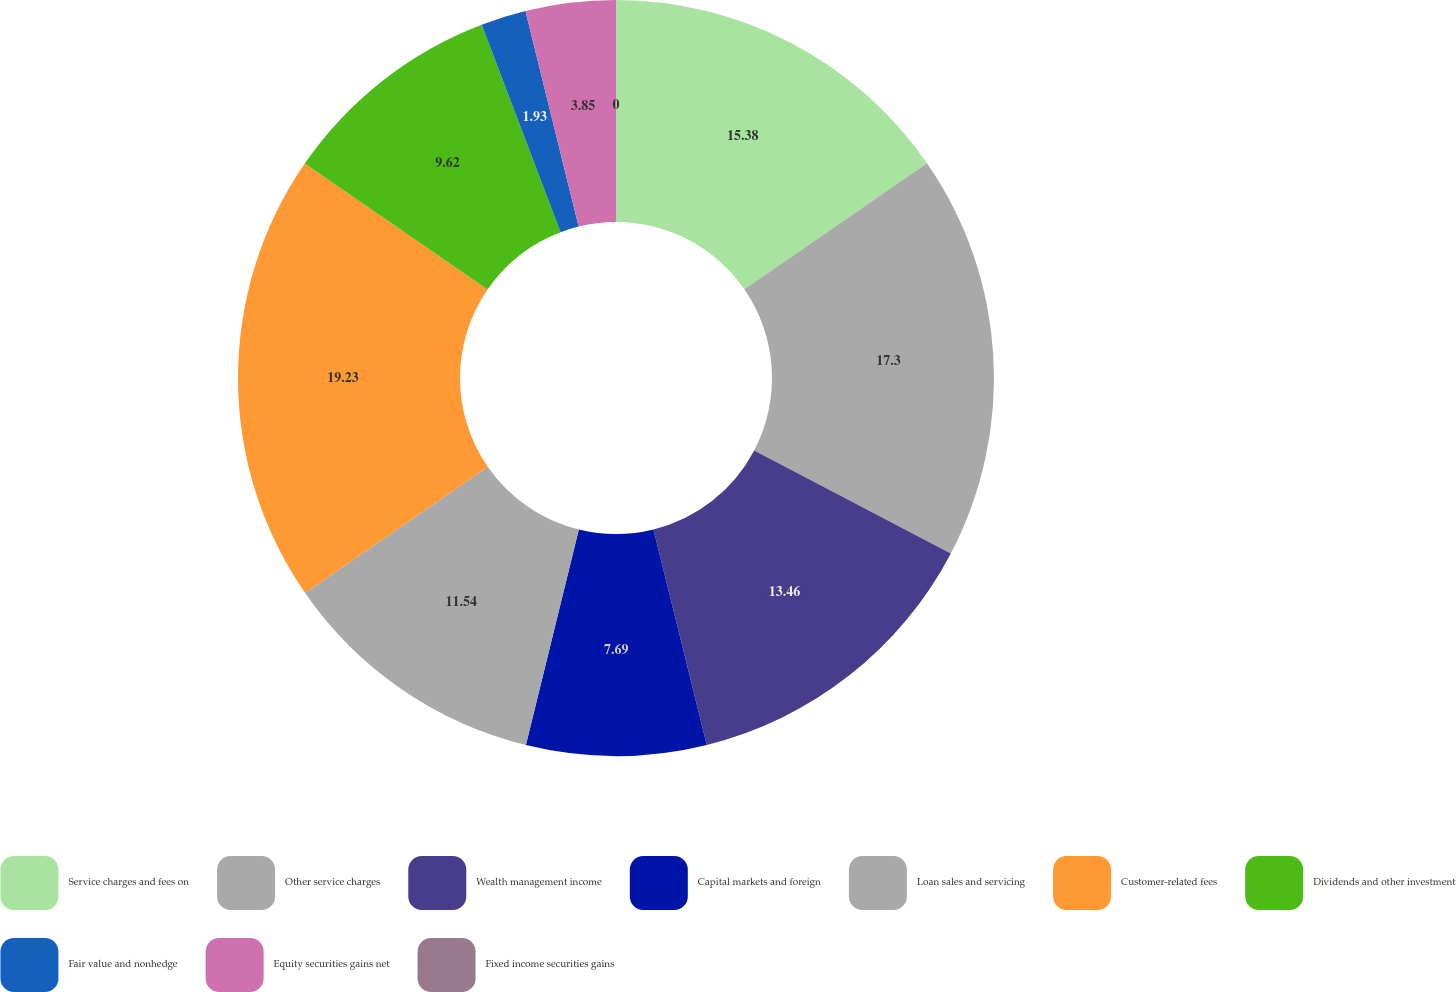Convert chart to OTSL. <chart><loc_0><loc_0><loc_500><loc_500><pie_chart><fcel>Service charges and fees on<fcel>Other service charges<fcel>Wealth management income<fcel>Capital markets and foreign<fcel>Loan sales and servicing<fcel>Customer-related fees<fcel>Dividends and other investment<fcel>Fair value and nonhedge<fcel>Equity securities gains net<fcel>Fixed income securities gains<nl><fcel>15.38%<fcel>17.3%<fcel>13.46%<fcel>7.69%<fcel>11.54%<fcel>19.23%<fcel>9.62%<fcel>1.93%<fcel>3.85%<fcel>0.0%<nl></chart> 